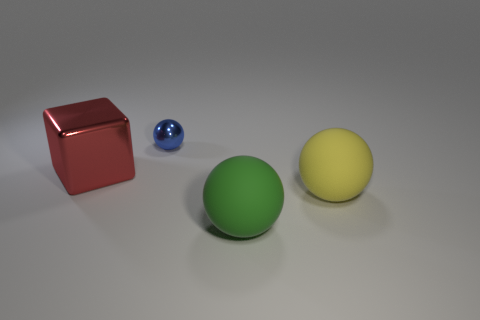Subtract all big green balls. How many balls are left? 2 Add 3 big gray things. How many objects exist? 7 Subtract all green balls. How many balls are left? 2 Subtract 3 spheres. How many spheres are left? 0 Subtract all blue cylinders. How many yellow balls are left? 1 Subtract all big green balls. Subtract all cyan matte blocks. How many objects are left? 3 Add 1 small metallic balls. How many small metallic balls are left? 2 Add 1 tiny gray cylinders. How many tiny gray cylinders exist? 1 Subtract 0 cyan cylinders. How many objects are left? 4 Subtract all blocks. How many objects are left? 3 